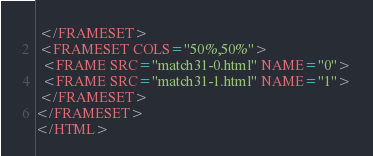Convert code to text. <code><loc_0><loc_0><loc_500><loc_500><_HTML_> </FRAMESET>
 <FRAMESET COLS="50%,50%">
  <FRAME SRC="match31-0.html" NAME="0">
  <FRAME SRC="match31-1.html" NAME="1">
 </FRAMESET>
</FRAMESET>
</HTML>
</code> 